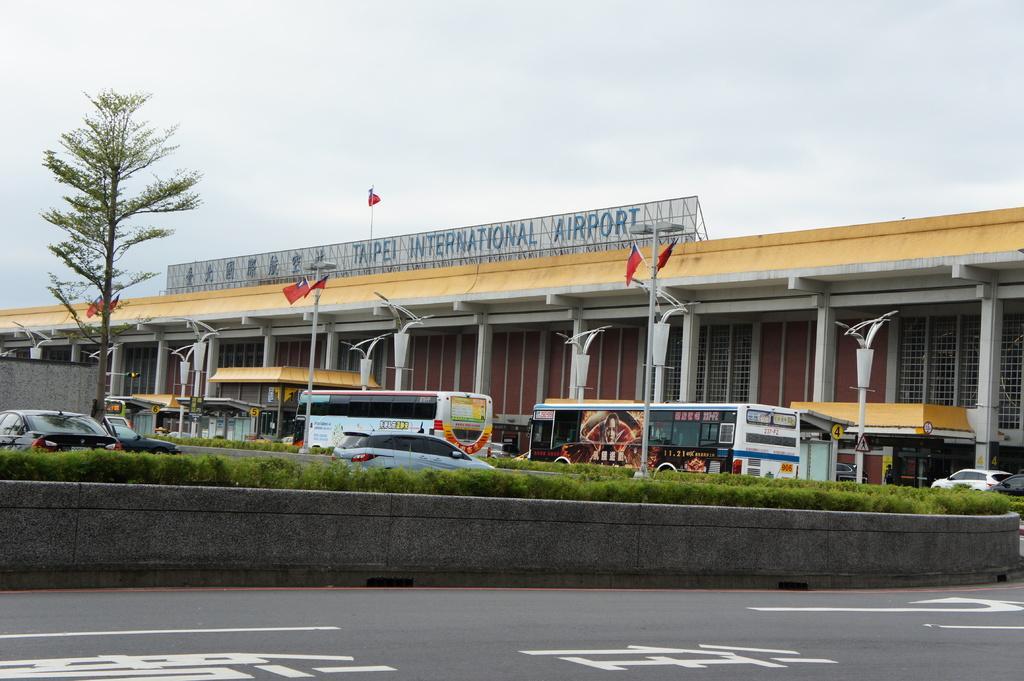Can you describe this image briefly? This picture shows an airport building and we see flags to the pole lights and we see couple of buses and cars and we see a tree and a flag on the building and we see a cloudy sky. 